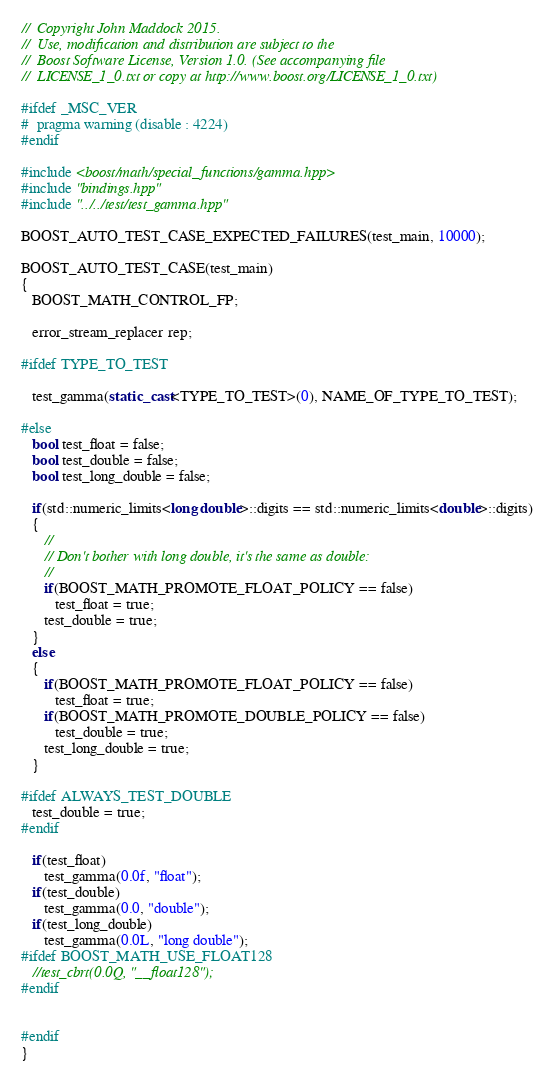Convert code to text. <code><loc_0><loc_0><loc_500><loc_500><_C++_>//  Copyright John Maddock 2015.
//  Use, modification and distribution are subject to the
//  Boost Software License, Version 1.0. (See accompanying file
//  LICENSE_1_0.txt or copy at http://www.boost.org/LICENSE_1_0.txt)

#ifdef _MSC_VER
#  pragma warning (disable : 4224)
#endif

#include <boost/math/special_functions/gamma.hpp>
#include "bindings.hpp"
#include "../../test/test_gamma.hpp"

BOOST_AUTO_TEST_CASE_EXPECTED_FAILURES(test_main, 10000);

BOOST_AUTO_TEST_CASE(test_main)
{
   BOOST_MATH_CONTROL_FP;

   error_stream_replacer rep;

#ifdef TYPE_TO_TEST

   test_gamma(static_cast<TYPE_TO_TEST>(0), NAME_OF_TYPE_TO_TEST);

#else
   bool test_float = false;
   bool test_double = false;
   bool test_long_double = false;

   if(std::numeric_limits<long double>::digits == std::numeric_limits<double>::digits)
   {
      //
      // Don't bother with long double, it's the same as double:
      //
      if(BOOST_MATH_PROMOTE_FLOAT_POLICY == false)
         test_float = true;
      test_double = true;
   }
   else
   {
      if(BOOST_MATH_PROMOTE_FLOAT_POLICY == false)
         test_float = true;
      if(BOOST_MATH_PROMOTE_DOUBLE_POLICY == false)
         test_double = true;
      test_long_double = true;
   }

#ifdef ALWAYS_TEST_DOUBLE
   test_double = true;
#endif

   if(test_float)
      test_gamma(0.0f, "float");
   if(test_double)
      test_gamma(0.0, "double");
   if(test_long_double)
      test_gamma(0.0L, "long double");
#ifdef BOOST_MATH_USE_FLOAT128
   //test_cbrt(0.0Q, "__float128");
#endif


#endif
}

</code> 